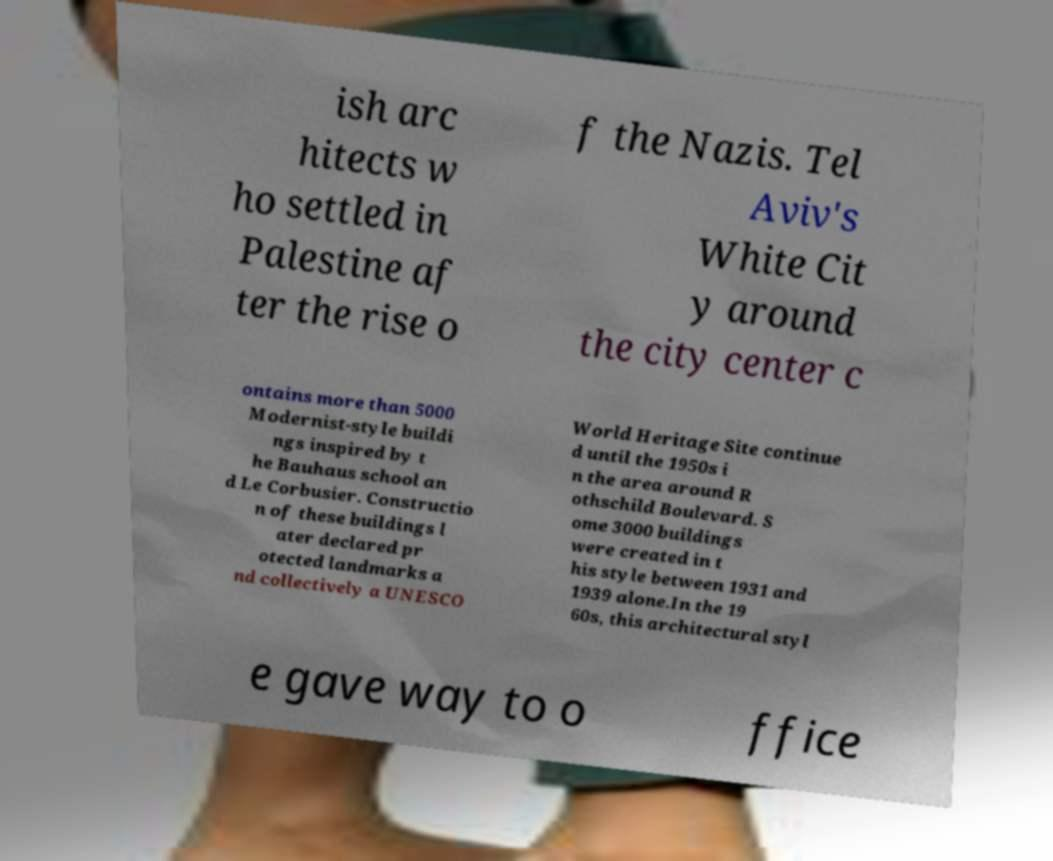Please identify and transcribe the text found in this image. ish arc hitects w ho settled in Palestine af ter the rise o f the Nazis. Tel Aviv's White Cit y around the city center c ontains more than 5000 Modernist-style buildi ngs inspired by t he Bauhaus school an d Le Corbusier. Constructio n of these buildings l ater declared pr otected landmarks a nd collectively a UNESCO World Heritage Site continue d until the 1950s i n the area around R othschild Boulevard. S ome 3000 buildings were created in t his style between 1931 and 1939 alone.In the 19 60s, this architectural styl e gave way to o ffice 